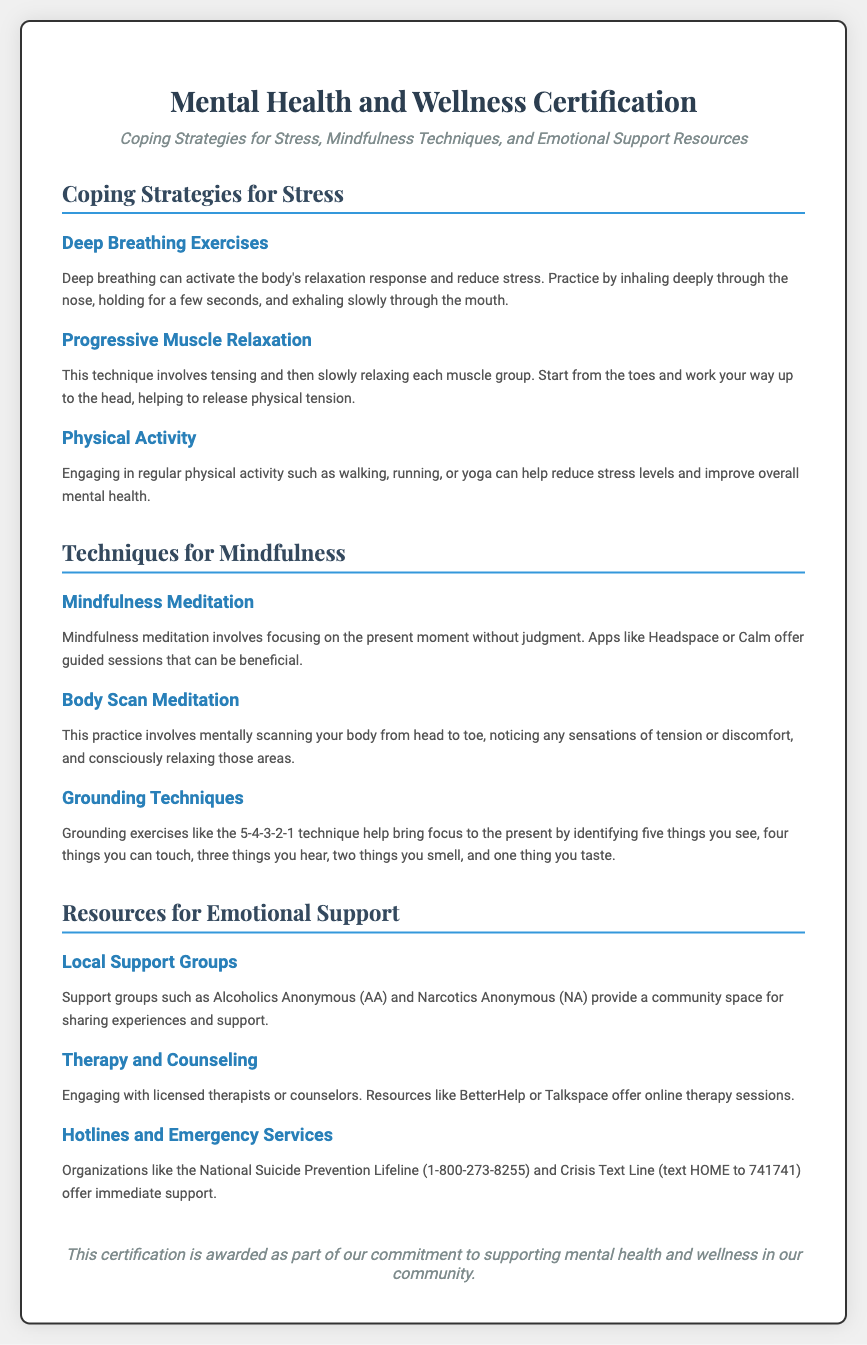What is the title of the certification? The title is prominently displayed at the top of the diploma document.
Answer: Mental Health and Wellness Certification What is one technique mentioned for coping with stress? The document lists several techniques under the coping strategies section.
Answer: Deep Breathing Exercises Which organization offers support through local groups? The document mentions specific support organizations focused on sharing experiences and support.
Answer: Alcoholics Anonymous (AA) How many mindfulness techniques are listed? The document provides a count of the mindfulness techniques in the corresponding section.
Answer: Three What is the contact method for the Crisis Text Line? The document specifies how to reach the Crisis Text Line for support.
Answer: text HOME to 741741 What does the footer indicate about the purpose of the certification? The footer summarizes the commitment reflected in the document.
Answer: Supporting mental health and wellness in our community What technique involves noticing sensations from head to toe? The description of this technique is provided in the mindfulness techniques section.
Answer: Body Scan Meditation What is the hotline number for the National Suicide Prevention Lifeline? This information is specifically provided under the resources for emotional support section.
Answer: 1-800-273-8255 